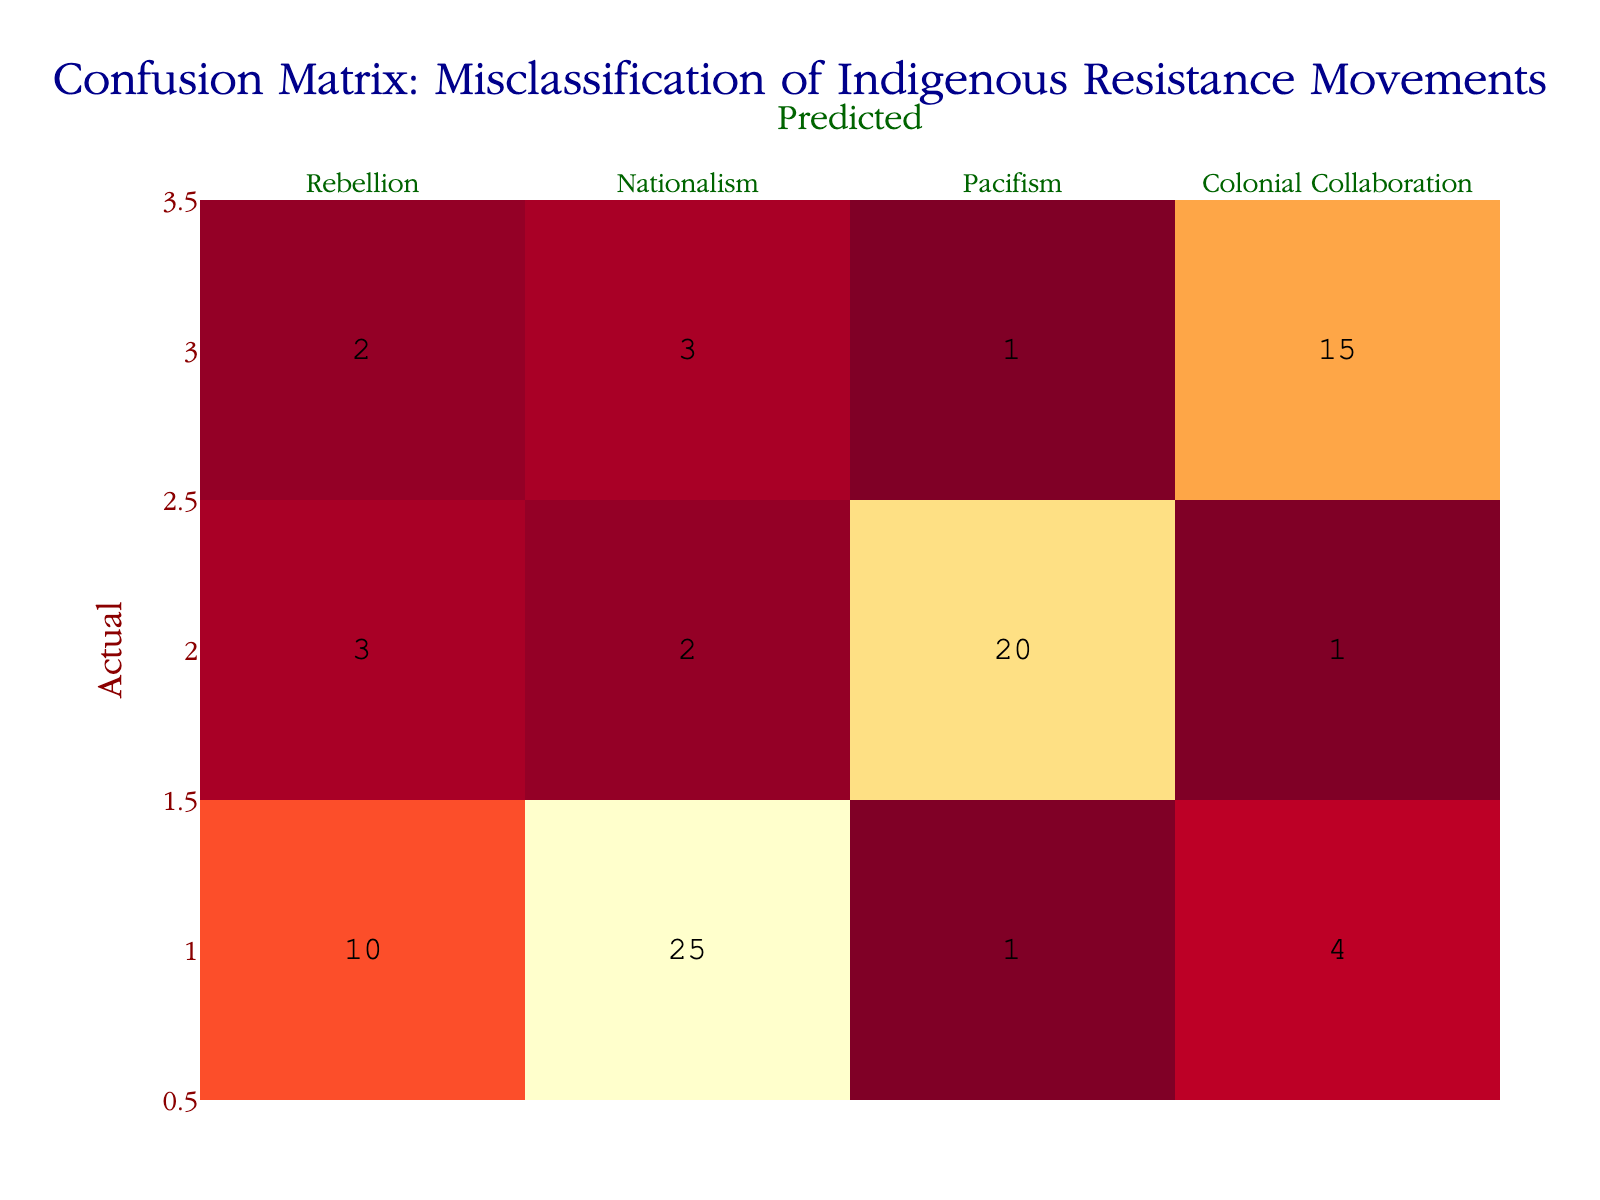What is the number of instances classified as a Rebellion that were actually Pacifism? The table shows the row for "Rebellion" and the column for "Pacifism". The value in that intersection is 2, indicating that 2 instances were misclassified as Rebellion when they were actually Pacifism.
Answer: 2 How many instances were predicted as Colonial Collaboration from actual Rebellion movements? Referring to the "Rebellion" row and "Colonial Collaboration" column, the value is 1. This means 1 instance of Rebellion was incorrectly predicted as Colonial Collaboration.
Answer: 1 What percentage of Nationalism instances were correctly predicted? The total actual instances of Nationalism is 40 (10+25+1+4). The correctly predicted instances are in the diagonal, which is 25. The percentage is (25/40) * 100 = 62.5%.
Answer: 62.5% Is there a higher number of instances misclassified as Nationalism or Pacifism for actual Rebellions? The misclassifications for Rebellions are 5 (to Nationalism) and 2 (to Pacifism). Since 5 > 2, there are more instances misclassified as Nationalism.
Answer: Yes What is the total number of instances predicted as Pacifism? To find this total, sum the values in the Pacifism column: 2 (from Rebellion) + 1 (from Nationalism) + 20 (from Pacifism) + 1 (from Colonial Collaboration) = 24.
Answer: 24 How many more instances were correctly classified as Pacifism than misclassified as Nationalism? The correctly classified instances of Pacifism is 20, and the misclassified instances as Nationalism (for actual Pacifism) is 2. The difference is 20 - 2 = 18.
Answer: 18 What proportion of actual Colonial Collaboration instances were misclassified as Rebellion? The actual instances of Colonial Collaboration are 21 (2+3+1+15). The misclassification to Rebellion is 2. The proportion is 2/21 ≈ 0.095 or 9.5%.
Answer: 9.5% Which resistance movement has the highest misclassification rate to another category? The highest misclassification for Rebellion (5 to Nationalism) and Colonial Collaboration (3 to Nationalism) matches up against Pacifism (3 to Rebellion). The highest would be from Rebellion to Nationalism.
Answer: Rebellion to Nationalism How many actual instances were misclassified into more than one category? Analyzing the rows, we see that the Rebellion has 3 misclassifications (to Nationalism, Pacifism, and Colonial Collaboration), while the Nationalism and Colonial Collaboration have misclassifications in two categories. Thus only Rebellion is misclassified in three categories.
Answer: 1 